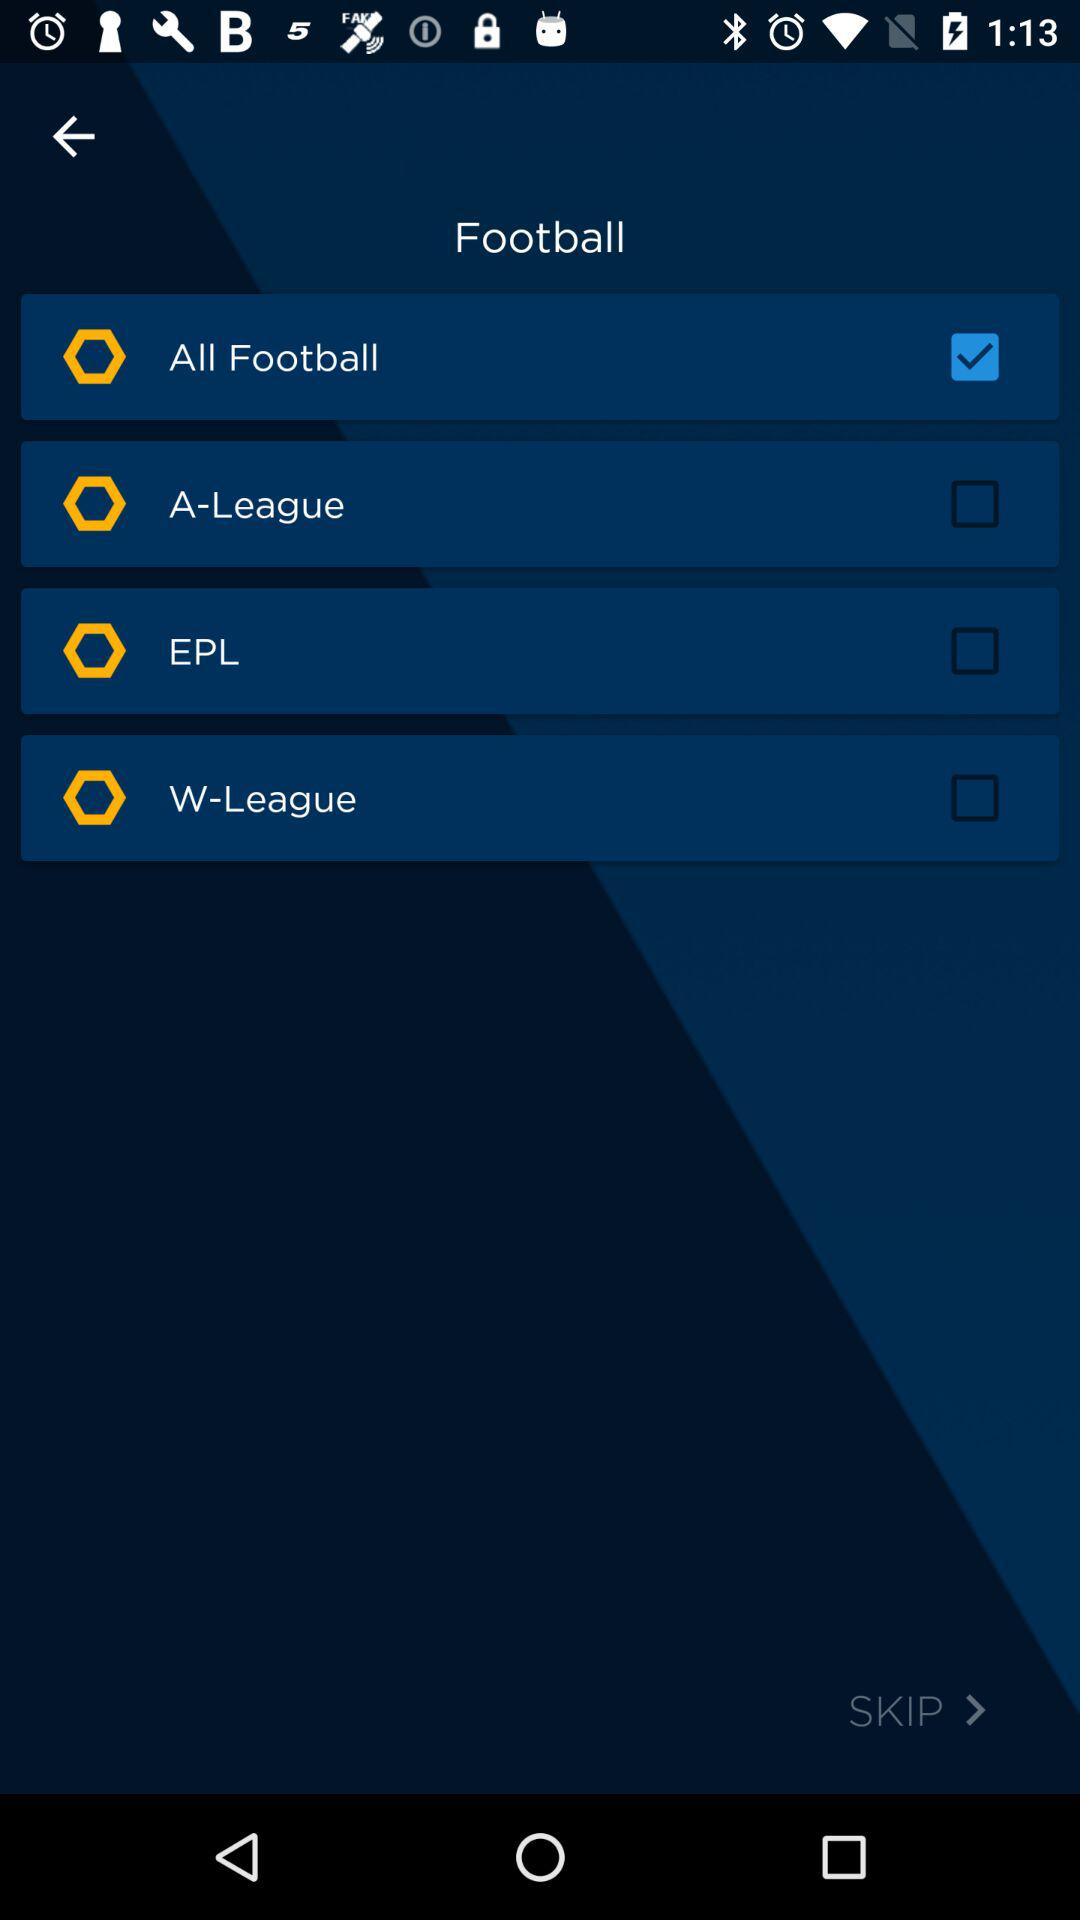What is the status of "All Football"? The status is "on". 